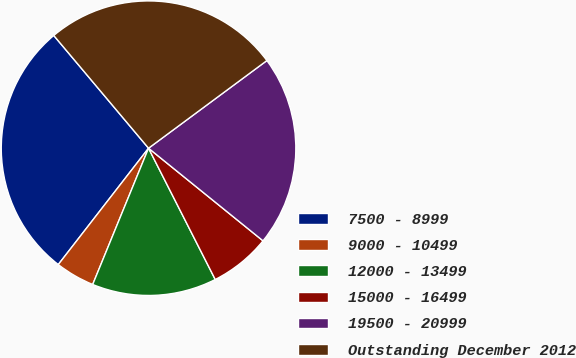Convert chart. <chart><loc_0><loc_0><loc_500><loc_500><pie_chart><fcel>7500 - 8999<fcel>9000 - 10499<fcel>12000 - 13499<fcel>15000 - 16499<fcel>19500 - 20999<fcel>Outstanding December 2012<nl><fcel>28.37%<fcel>4.31%<fcel>13.67%<fcel>6.69%<fcel>20.97%<fcel>25.98%<nl></chart> 